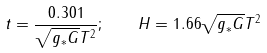<formula> <loc_0><loc_0><loc_500><loc_500>t = \frac { 0 . 3 0 1 } { \sqrt { g _ { * } G } T ^ { 2 } } ; \quad H = 1 . 6 6 \sqrt { g _ { * } G } T ^ { 2 }</formula> 